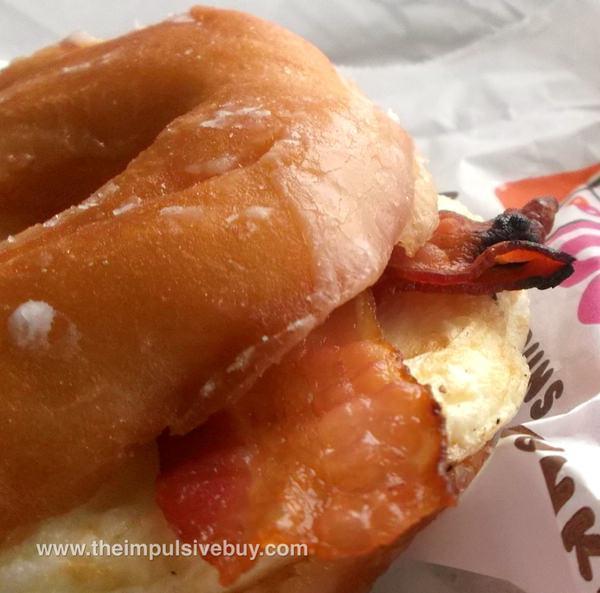How many donuts are in the plate?
Give a very brief answer. 2. How many donuts are there?
Give a very brief answer. 2. 